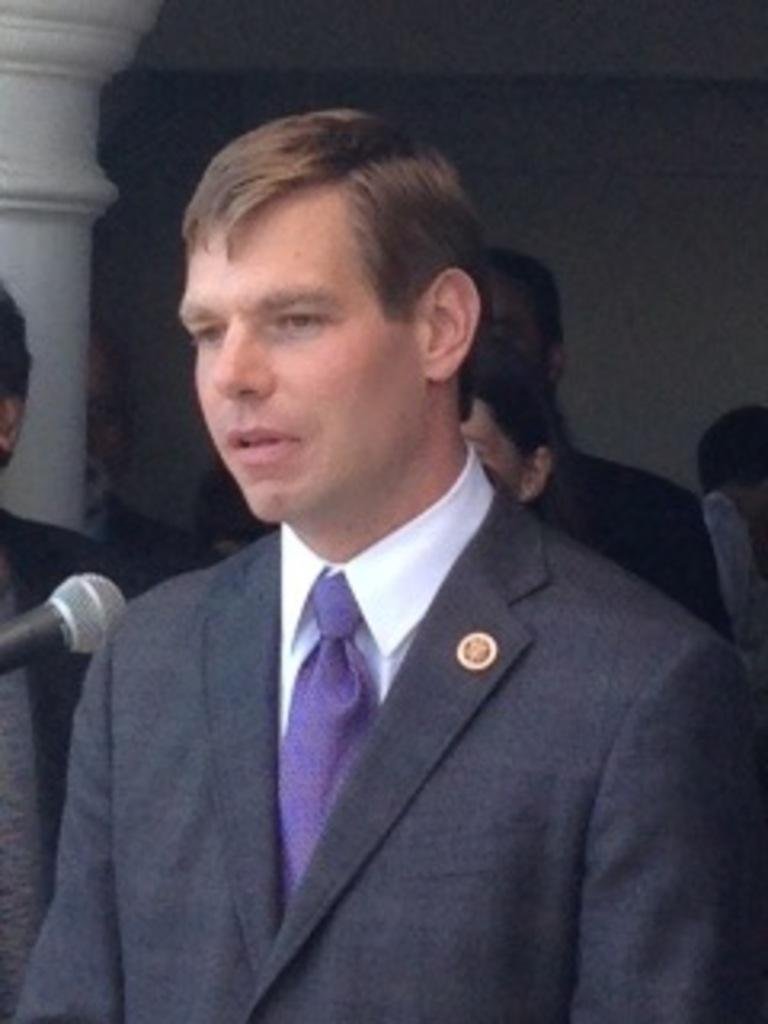Who is the main subject in the image? There is a man in the image. What is in front of the man? There is a mic in front of the man. Are there any other people visible in the image? Yes, there are other people behind the man. What architectural feature can be seen in the image? There is a pillar in the image. What type of bag is the man carrying in the image? There is no bag visible in the image. What liquid is being poured by the man in the image? The man is not pouring any liquid in the image; he is standing in front of a mic. 